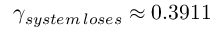<formula> <loc_0><loc_0><loc_500><loc_500>\gamma _ { s y s t e m \, l o s e s } \approx 0 . 3 9 1 1</formula> 